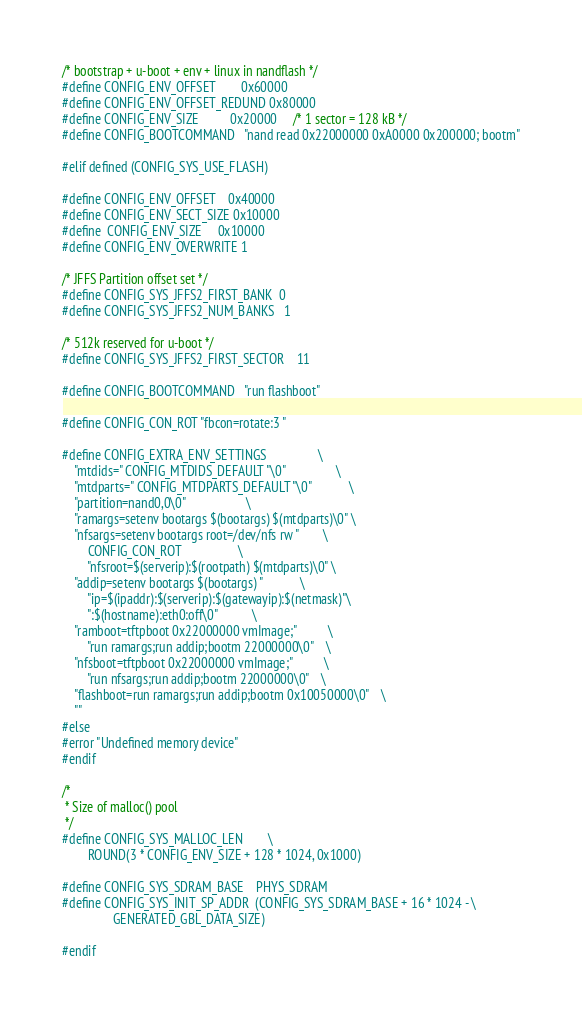Convert code to text. <code><loc_0><loc_0><loc_500><loc_500><_C_>/* bootstrap + u-boot + env + linux in nandflash */
#define CONFIG_ENV_OFFSET		0x60000
#define CONFIG_ENV_OFFSET_REDUND	0x80000
#define CONFIG_ENV_SIZE			0x20000		/* 1 sector = 128 kB */
#define CONFIG_BOOTCOMMAND	"nand read 0x22000000 0xA0000 0x200000; bootm"

#elif defined (CONFIG_SYS_USE_FLASH)

#define CONFIG_ENV_OFFSET	0x40000
#define CONFIG_ENV_SECT_SIZE	0x10000
#define	CONFIG_ENV_SIZE		0x10000
#define CONFIG_ENV_OVERWRITE	1

/* JFFS Partition offset set */
#define CONFIG_SYS_JFFS2_FIRST_BANK	0
#define CONFIG_SYS_JFFS2_NUM_BANKS	1

/* 512k reserved for u-boot */
#define CONFIG_SYS_JFFS2_FIRST_SECTOR	11

#define CONFIG_BOOTCOMMAND	"run flashboot"

#define CONFIG_CON_ROT "fbcon=rotate:3 "

#define CONFIG_EXTRA_ENV_SETTINGS				\
	"mtdids=" CONFIG_MTDIDS_DEFAULT "\0"				\
	"mtdparts=" CONFIG_MTDPARTS_DEFAULT "\0"			\
	"partition=nand0,0\0"					\
	"ramargs=setenv bootargs $(bootargs) $(mtdparts)\0"	\
	"nfsargs=setenv bootargs root=/dev/nfs rw "		\
		CONFIG_CON_ROT					\
		"nfsroot=$(serverip):$(rootpath) $(mtdparts)\0"	\
	"addip=setenv bootargs $(bootargs) "			\
		"ip=$(ipaddr):$(serverip):$(gatewayip):$(netmask)"\
		":$(hostname):eth0:off\0"			\
	"ramboot=tftpboot 0x22000000 vmImage;"			\
		"run ramargs;run addip;bootm 22000000\0"	\
	"nfsboot=tftpboot 0x22000000 vmImage;"			\
		"run nfsargs;run addip;bootm 22000000\0"	\
	"flashboot=run ramargs;run addip;bootm 0x10050000\0"	\
	""
#else
#error "Undefined memory device"
#endif

/*
 * Size of malloc() pool
 */
#define CONFIG_SYS_MALLOC_LEN		\
		ROUND(3 * CONFIG_ENV_SIZE + 128 * 1024, 0x1000)

#define CONFIG_SYS_SDRAM_BASE	PHYS_SDRAM
#define CONFIG_SYS_INIT_SP_ADDR	(CONFIG_SYS_SDRAM_BASE + 16 * 1024 - \
				GENERATED_GBL_DATA_SIZE)

#endif
</code> 